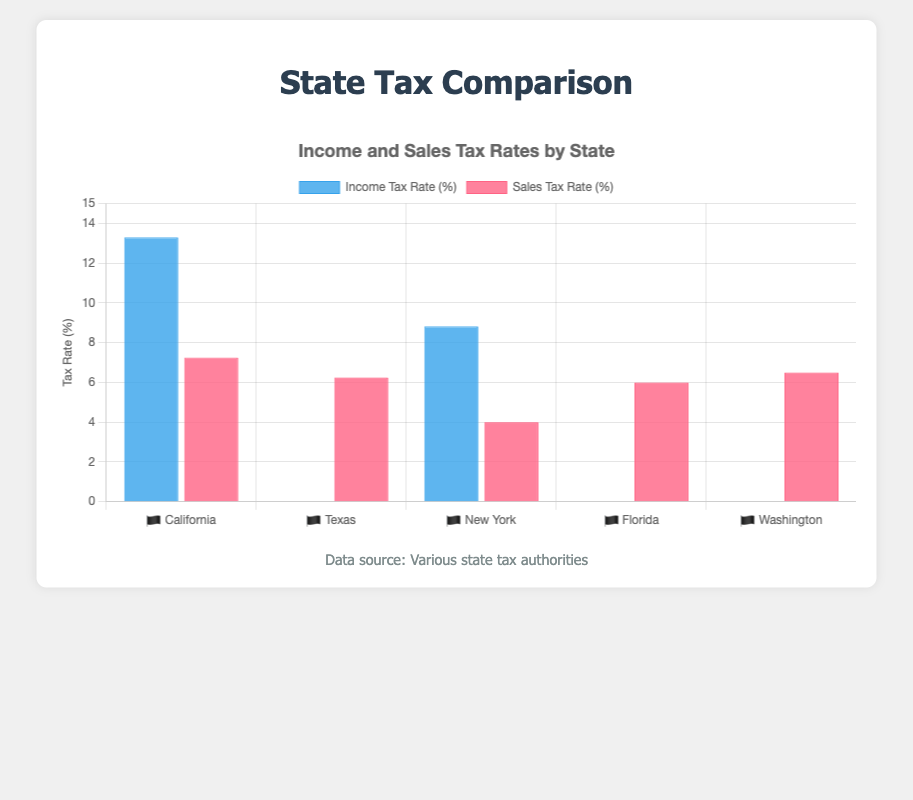Which state has the highest income tax rate? By examining the income tax rates on the chart, identify the state with the highest value. In this case, it's California at 13.3%
Answer: California Which states have no income tax? Check the income tax rates noting the states with a 0% tax rate. Texas, Florida, and Washington all have 0% income tax.
Answer: Texas, Florida, Washington What's the average sales tax rate of all listed states? Add up all the sales tax rates of the states (7.25 + 6.25 + 4 + 6 + 6.5) and then divide by the number of states, which is 5. Average = (7.25 + 6.25 + 4 + 6 + 6.5) / 5 = 6.
Answer: 6 Which state has the lowest sales tax rate? Compare the sales tax rates and identify the state with the lowest value. New York has the lowest sales tax rate at 4%.
Answer: New York How many states listed have an income tax rate above 0%? Count the number of states with an income tax rate greater than 0%. California and New York both have an income tax rate above 0%.
Answer: 2 Which states have a sales tax rate of 6% or more? Identify states where the sales tax rate is 6% or higher. These states are California, Texas, Florida, and Washington.
Answer: California, Texas, Florida, Washington Comparing California and Texas, which has higher overall tax rates (income + sales)? Add the income tax rate and sales tax rate for both states and compare. California: 13.3 + 7.25 = 20.55, Texas: 0 + 6.25 = 6.25. California has higher overall tax rates.
Answer: California What are the total tax rates (income + sales) for Washington? Add the income tax rate and sales tax rate for Washington. 0 (income) + 6.5 (sales) = 6.5.
Answer: 6.5 If New York were to increase its sales tax by 1%, how would its new sales tax rate compare to Florida's? Increase New York's sales tax rate by 1% from 4% to 5% and then compare it to Florida's 6%. 5% is still less than Florida's 6%.
Answer: New York's new rate would still be lower than Florida's Which state has a higher combined tax rate, New York or Florida? Add the income and sales tax rates for New York and Florida respectively. New York: 8.82 + 4 = 12.82, Florida: 0 + 6 = 6. New York has a higher combined tax rate.
Answer: New York 